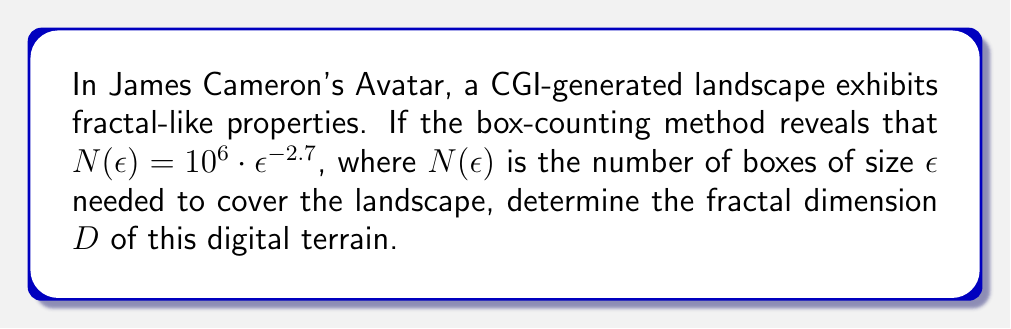Give your solution to this math problem. To determine the fractal dimension of the CGI-generated landscape in Avatar, we'll use the box-counting method and the given relationship:

1) The general form of the box-counting dimension is:
   $$D = \lim_{\epsilon \to 0} \frac{\log N(\epsilon)}{\log(1/\epsilon)}$$

2) We're given that $N(\epsilon) = 10^6 \cdot \epsilon^{-2.7}$

3) Taking the logarithm of both sides:
   $$\log N(\epsilon) = \log(10^6 \cdot \epsilon^{-2.7}) = \log(10^6) + \log(\epsilon^{-2.7})$$

4) Simplify:
   $$\log N(\epsilon) = 6 - 2.7 \log(\epsilon)$$

5) Rearranging to match the form of the box-counting dimension:
   $$\frac{\log N(\epsilon)}{\log(1/\epsilon)} = \frac{6 - 2.7 \log(\epsilon)}{-\log(\epsilon)} = 2.7 + \frac{6}{-\log(\epsilon)}$$

6) As $\epsilon \to 0$, $-\log(\epsilon) \to \infty$, so the second term approaches 0:
   $$\lim_{\epsilon \to 0} \frac{\log N(\epsilon)}{\log(1/\epsilon)} = 2.7$$

Therefore, the fractal dimension $D$ of the CGI-generated landscape is 2.7.
Answer: $D = 2.7$ 